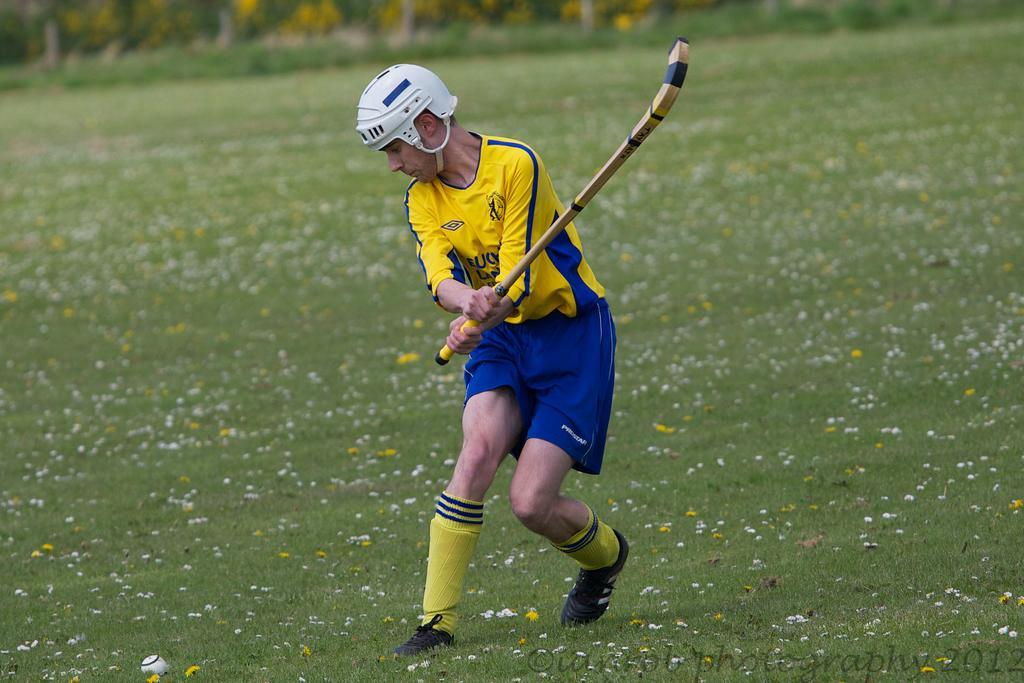How would you summarize this image in a sentence or two? In this picture we can see a man in the jersey. He is holding a hockey stick and on the grass there is a ball. Behind the man there is the blurred background. On the image there is a watermark. 